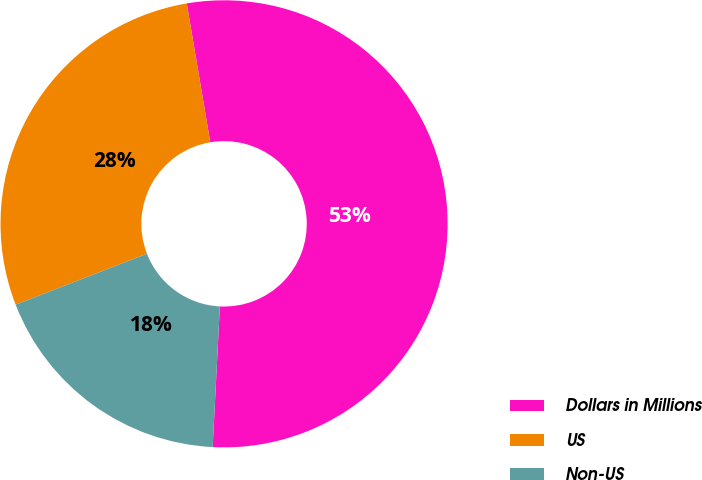<chart> <loc_0><loc_0><loc_500><loc_500><pie_chart><fcel>Dollars in Millions<fcel>US<fcel>Non-US<nl><fcel>53.48%<fcel>28.22%<fcel>18.3%<nl></chart> 